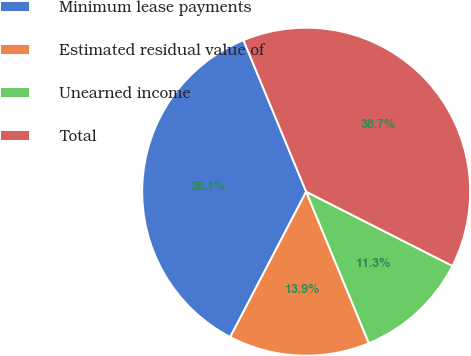Convert chart to OTSL. <chart><loc_0><loc_0><loc_500><loc_500><pie_chart><fcel>Minimum lease payments<fcel>Estimated residual value of<fcel>Unearned income<fcel>Total<nl><fcel>36.09%<fcel>13.91%<fcel>11.28%<fcel>38.72%<nl></chart> 